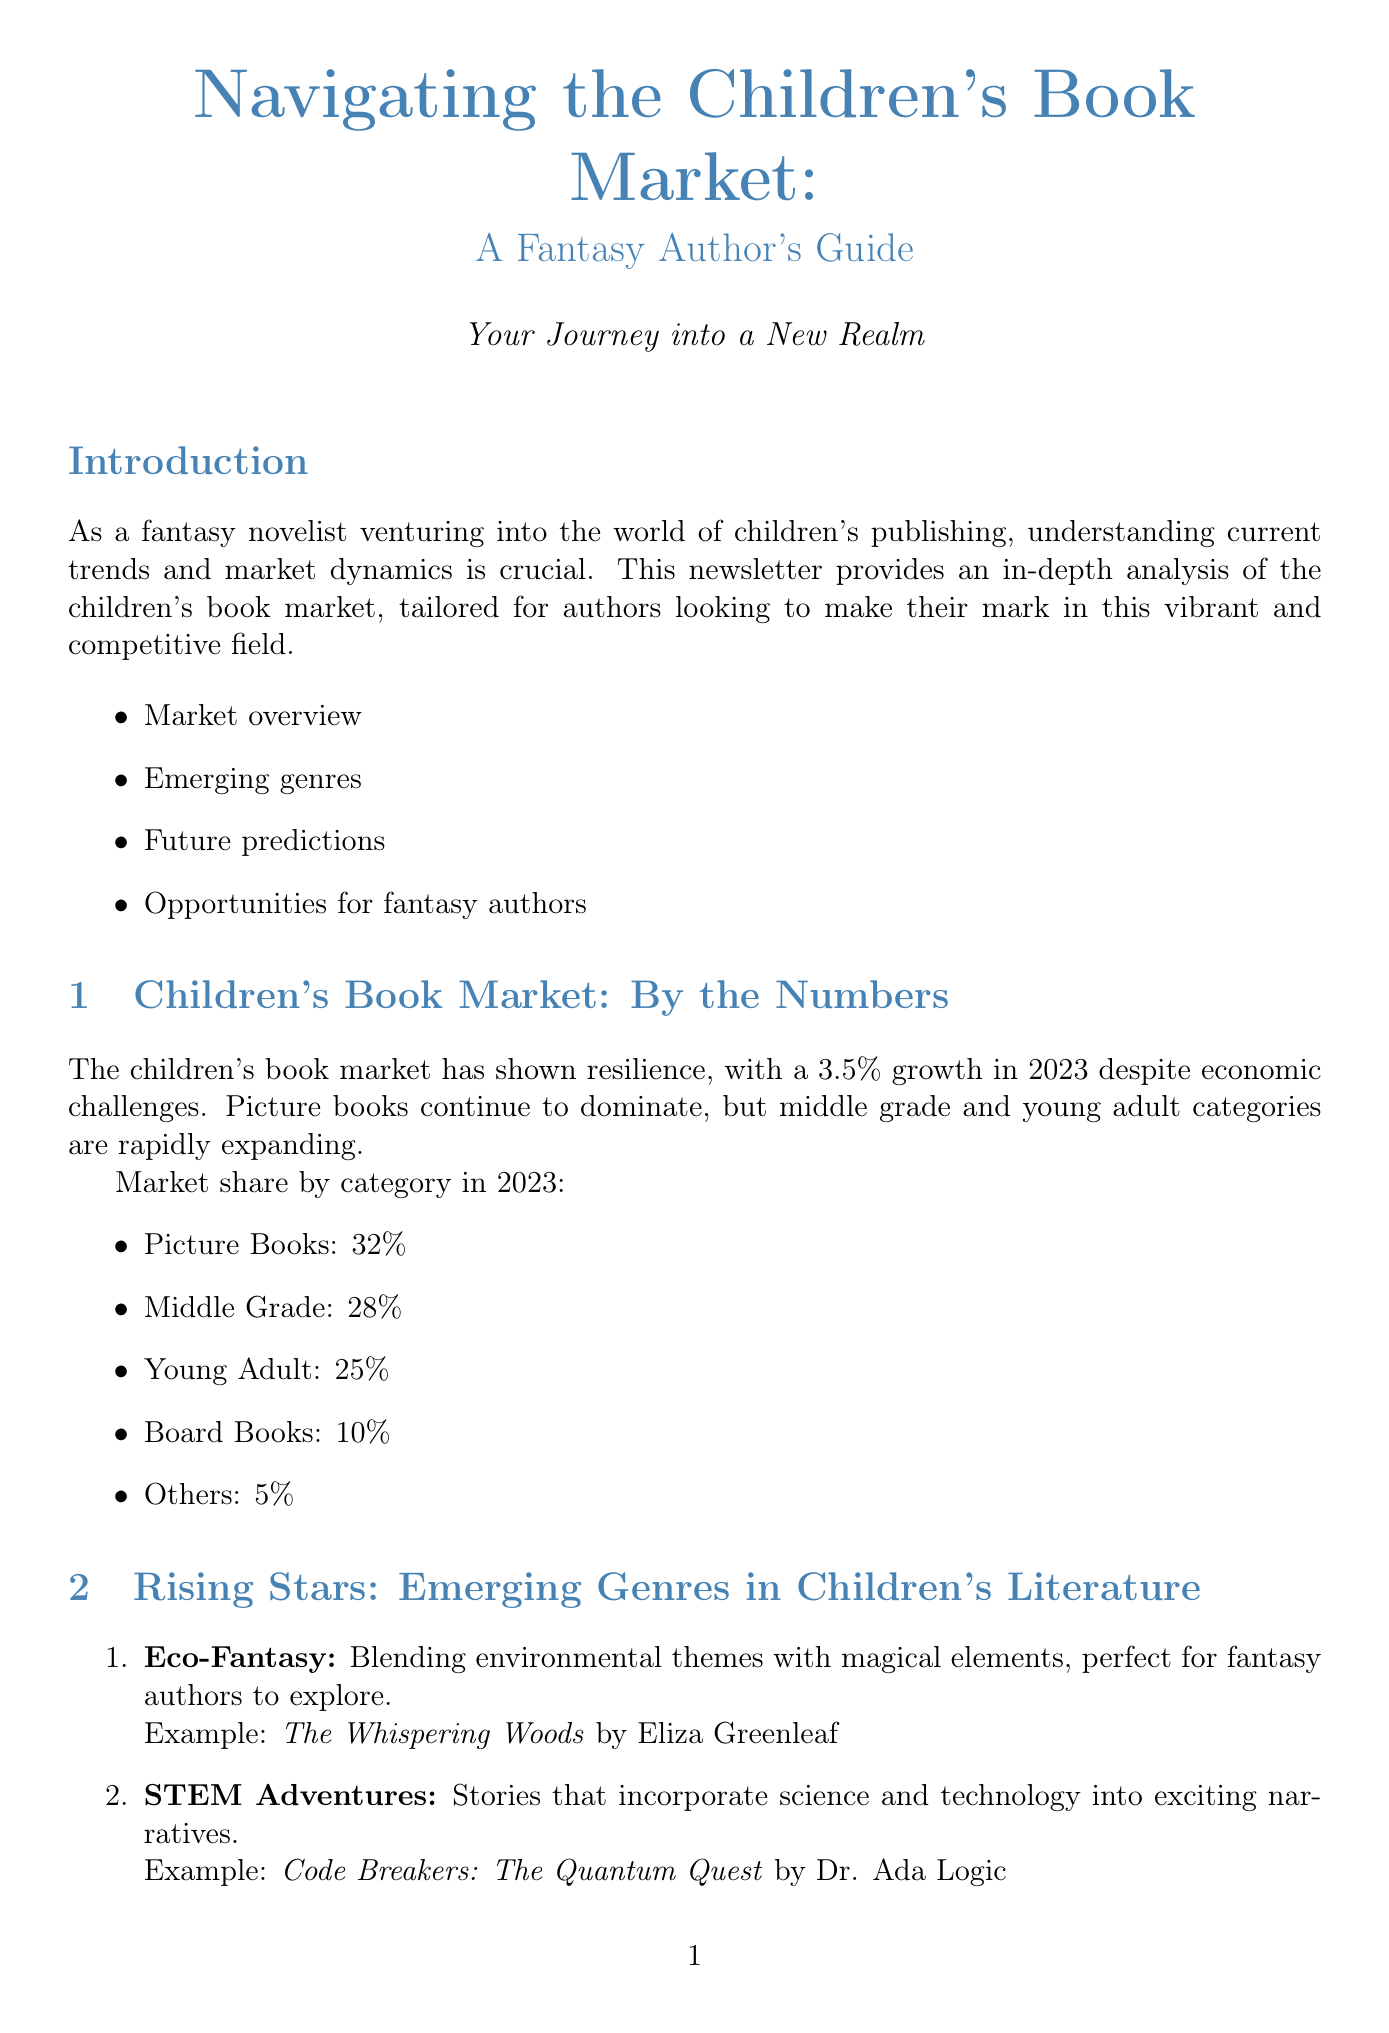What is the growth percentage of the children's book market in 2023? The growth percentage of the children's book market indicated in the document is stated as 3.5%.
Answer: 3.5% What category holds the largest market share in the children's book market? According to the infographic, Picture Books hold the largest market share at 32%.
Answer: Picture Books Which genre combines environmental themes with magical elements? The document identifies Eco-Fantasy as the genre that blends environmental themes with magical elements.
Answer: Eco-Fantasy What is the projected market share for ebooks in 2028? The document specifies that the projected market share for ebooks in 2028 is 25%.
Answer: 25% How many strategic pieces of advice are provided for fantasy authors? The document lists four strategic pieces of advice for fantasy authors to consider.
Answer: Four What is a key trend in the future of children's publishing? The document highlights the increase in interactive ebooks as one of the key trends.
Answer: Interactive ebooks Which author wrote "The Whispering Woods"? The document mentions Eliza Greenleaf as the author of "The Whispering Woods."
Answer: Eliza Greenleaf What type of book format is experiencing a rise in demand according to the predictions? The document indicates that serialized content and book series are formats that are experiencing a rise in demand.
Answer: Serialized content and book series 